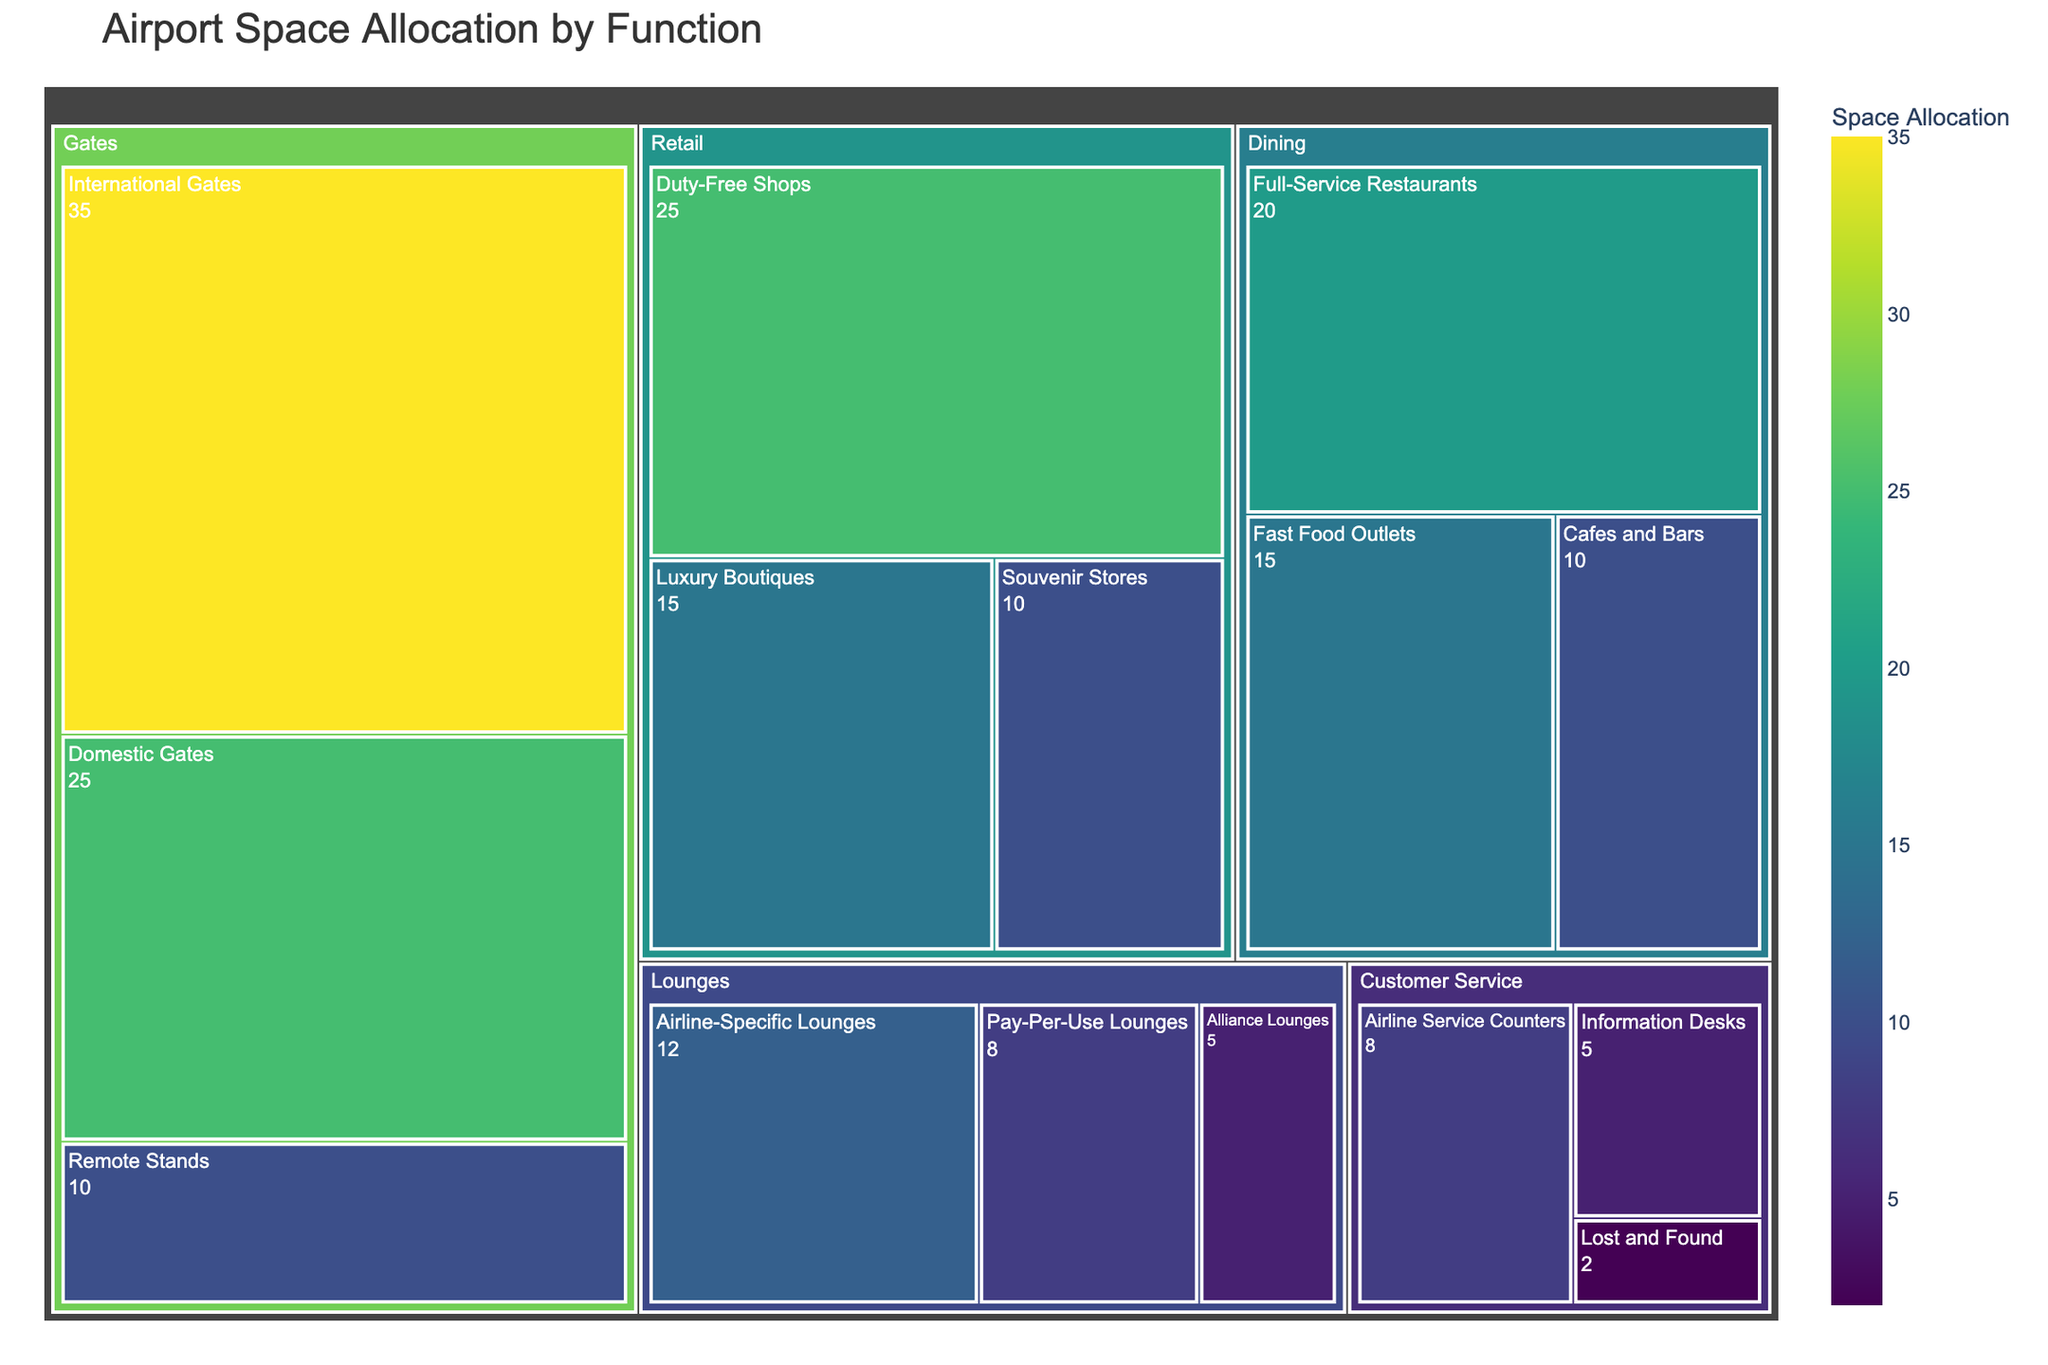What is the most allocated space category at the airport? The largest section in the treemap can be identified by the size of the box. "Gates" is the largest section, indicating it has the most allocated space.
Answer: Gates How much space in total is allocated to lounges? Sum the values of all the subcategories under "Lounges": (12 for Airline-Specific Lounges) + (8 for Pay-Per-Use Lounges) + (5 for Alliance Lounges) = 25%
Answer: 25% Which subcategory within Retail has the highest allocation? Among the subcategories under "Retail," the one with the largest box and highest value is "Duty-Free Shops" with 25%.
Answer: Duty-Free Shops Out of Dining and Retail, which category has a higher total allocation? Sum the values of the subcategories under "Dining" and "Retail" respectively. Dining: (20 for Full-Service Restaurants) + (15 for Fast Food Outlets) + (10 for Cafes and Bars) = 45%, Retail: (25 for Duty-Free Shops) + (15 for Luxury Boutiques) + (10 for Souvenir Stores) = 50%. Retail has a higher total allocation.
Answer: Retail What is the combined allocation of Information Desks and Airline Service Counters within the Customer Service category? Sum the values of "Information Desks" and "Airline Service Counters" under Customer Service: (5 for Information Desks) + (8 for Airline Service Counters) = 13%
Answer: 13% Which category has the least total allocated space? By comparing the total values of major categories (Retail, Dining, Lounges, Gates, Customer Service), "Customer Service" has the least with (5+8+2) = 15%.
Answer: Customer Service How does the allocation for Fast Food Outlets compare to Souvenir Stores? Compare the values directly, Fast Food Outlets have 15% and Souvenir Stores have 10%. Fast Food Outlets have a higher allocation.
Answer: Fast Food Outlets Which category's subcategories have the highest variation in space allocation? Compare the range (difference between highest and lowest subcategory allocations) within each category. Gates have the highest variation ranging from 35% (International Gates) to 10% (Remote Stands), while other categories have closer ranges.
Answer: Gates 